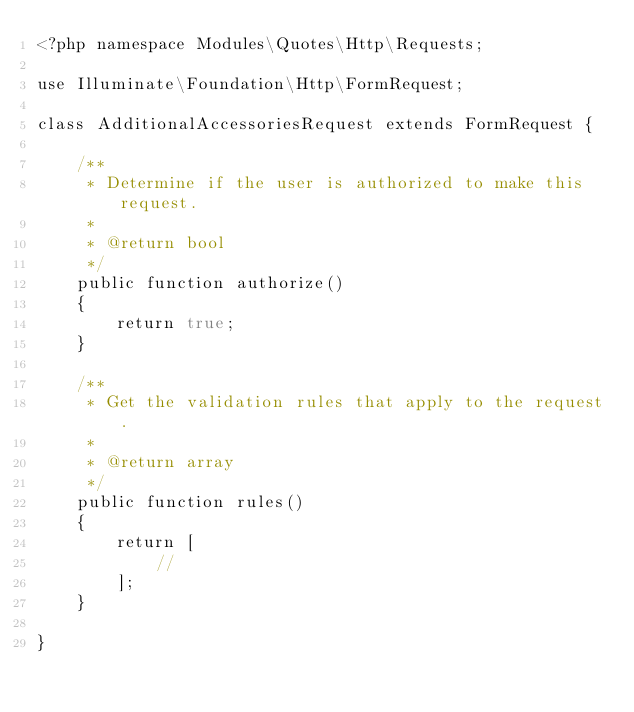Convert code to text. <code><loc_0><loc_0><loc_500><loc_500><_PHP_><?php namespace Modules\Quotes\Http\Requests;

use Illuminate\Foundation\Http\FormRequest;

class AdditionalAccessoriesRequest extends FormRequest {

	/**
	 * Determine if the user is authorized to make this request.
	 *
	 * @return bool
	 */
	public function authorize()
	{
		return true;
	}

	/**
	 * Get the validation rules that apply to the request.
	 *
	 * @return array
	 */
	public function rules()
	{
		return [
			//
		];
	}

}
</code> 